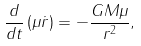Convert formula to latex. <formula><loc_0><loc_0><loc_500><loc_500>\frac { d } { d t } \left ( \mu \dot { r } \right ) = - \frac { G M \mu } { r ^ { 2 } } ,</formula> 